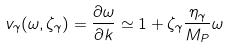Convert formula to latex. <formula><loc_0><loc_0><loc_500><loc_500>v _ { \gamma } ( \omega , \zeta _ { \gamma } ) = \frac { \partial \omega } { \partial k } \simeq 1 + \zeta _ { \gamma } \frac { \eta _ { \gamma } } { M _ { P } } \omega</formula> 